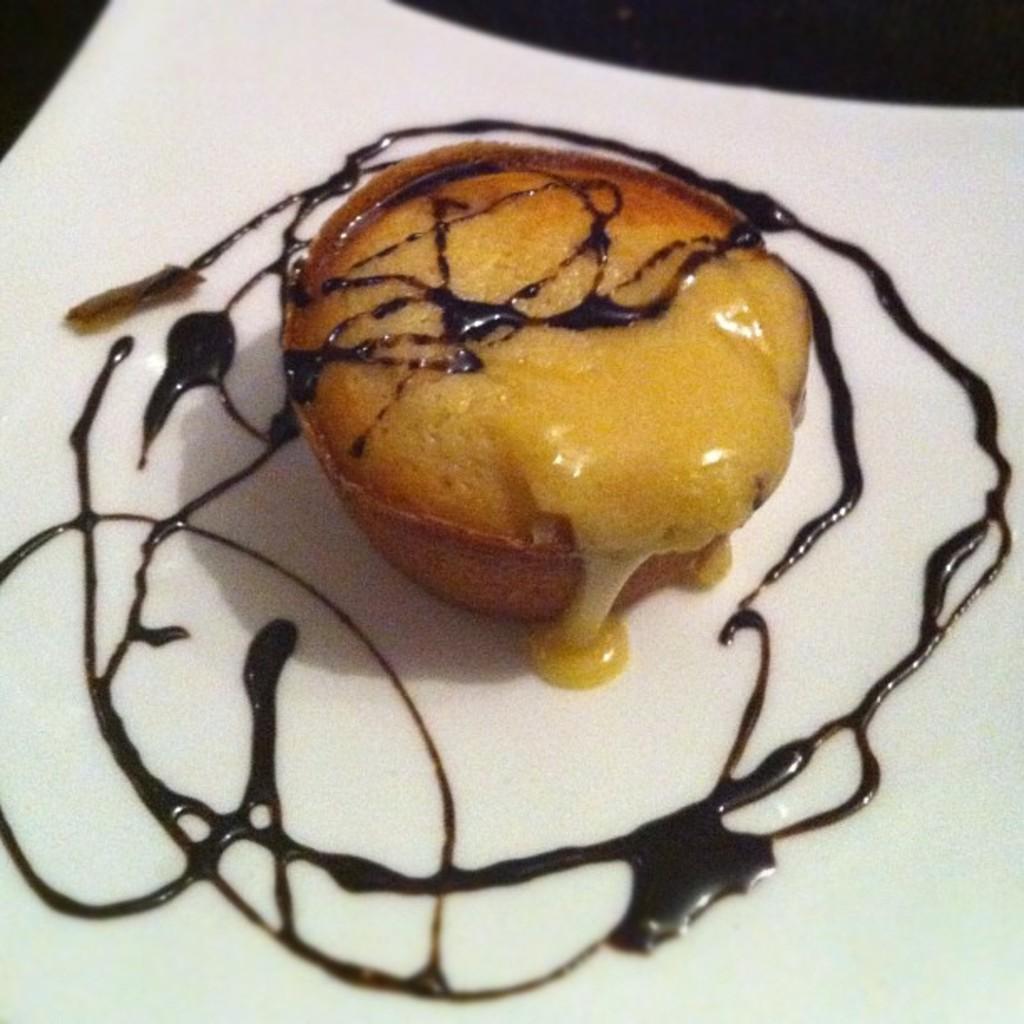In one or two sentences, can you explain what this image depicts? In this picture I can see there is some food placed on the plate and there is chocolate syrup on it. 